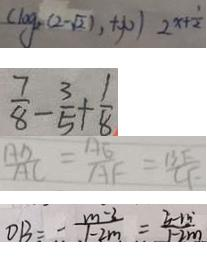Convert formula to latex. <formula><loc_0><loc_0><loc_500><loc_500>( \log _ { 2 } ( 2 - \sqrt { 2 1 } , + \infty ) 2 ^ { x + \frac { 1 } { 2 } } 
 \frac { 7 } { 8 } - \frac { 3 } { 5 } + \frac { 1 } { 8 } 
 \frac { A D } { A C } = \frac { A E } { A F } = \frac { B F } { C F } 
 O B = - \frac { m - 3 } { 1 - 2 m } = \frac { 3 - m ^ { \cdot } } { 1 - 2 m }</formula> 